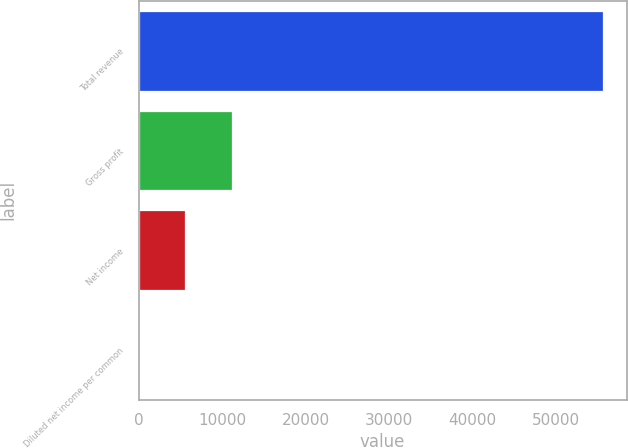Convert chart. <chart><loc_0><loc_0><loc_500><loc_500><bar_chart><fcel>Total revenue<fcel>Gross profit<fcel>Net income<fcel>Diluted net income per common<nl><fcel>55648<fcel>11129.7<fcel>5564.91<fcel>0.12<nl></chart> 